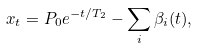Convert formula to latex. <formula><loc_0><loc_0><loc_500><loc_500>x _ { t } = P _ { 0 } e ^ { - t / T _ { 2 } } - \sum _ { i } \beta _ { i } ( t ) ,</formula> 